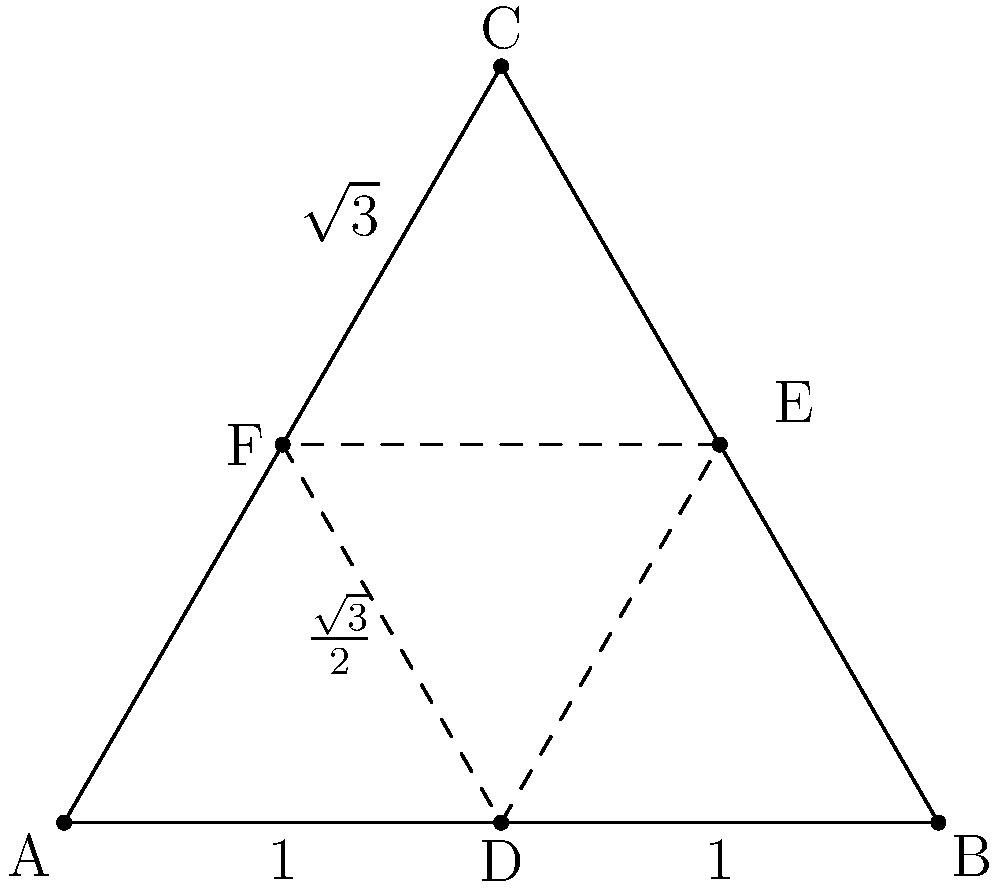In the sacred geometric pattern shown above, which represents a traditional tribal design, what is the ratio of the area of the inner triangle DEF to the area of the outer triangle ABC? To find the ratio of the areas, let's follow these steps:

1) First, we need to recognize that triangle ABC is an equilateral triangle with side length 4.

2) The inner triangle DEF is formed by connecting the midpoints of the sides of ABC. This is known as the medial triangle.

3) A key property of the medial triangle is that its area is always $\frac{1}{4}$ of the area of the original triangle.

4) To prove this:
   - The midpoint theorem states that a line segment joining the midpoints of two sides of a triangle is parallel to the third side and half the length.
   - This means each side of DEF is parallel to a side of ABC and half its length.
   - The height of DEF is also half the height of ABC.
   - Therefore, the area of DEF is $\frac{1}{2} \times \frac{1}{2} = \frac{1}{4}$ of the area of ABC.

5) Thus, the ratio of the area of DEF to the area of ABC is 1:4 or $\frac{1}{4}$.

This ratio is consistent across all equilateral triangles and represents a fundamental principle in sacred geometry, symbolizing harmony and balance in traditional designs.
Answer: $\frac{1}{4}$ 